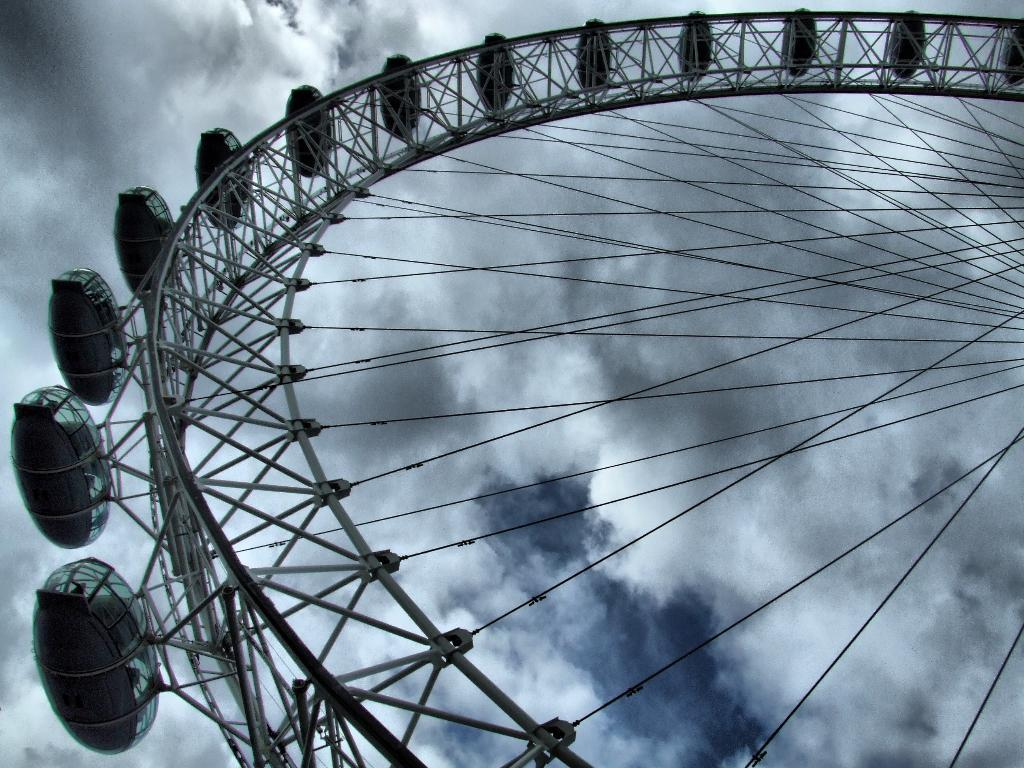What is the main subject of the image? The main subject of the image is a part of a giant wheel. What can be seen in the background of the image? The sky is visible in the background of the image. What is the condition of the sky in the image? Clouds are present in the sky. What type of pet can be seen playing with a low-hanging branch in the image? There is no pet or low-hanging branch present in the image; it features a part of a giant wheel and a sky with clouds. 